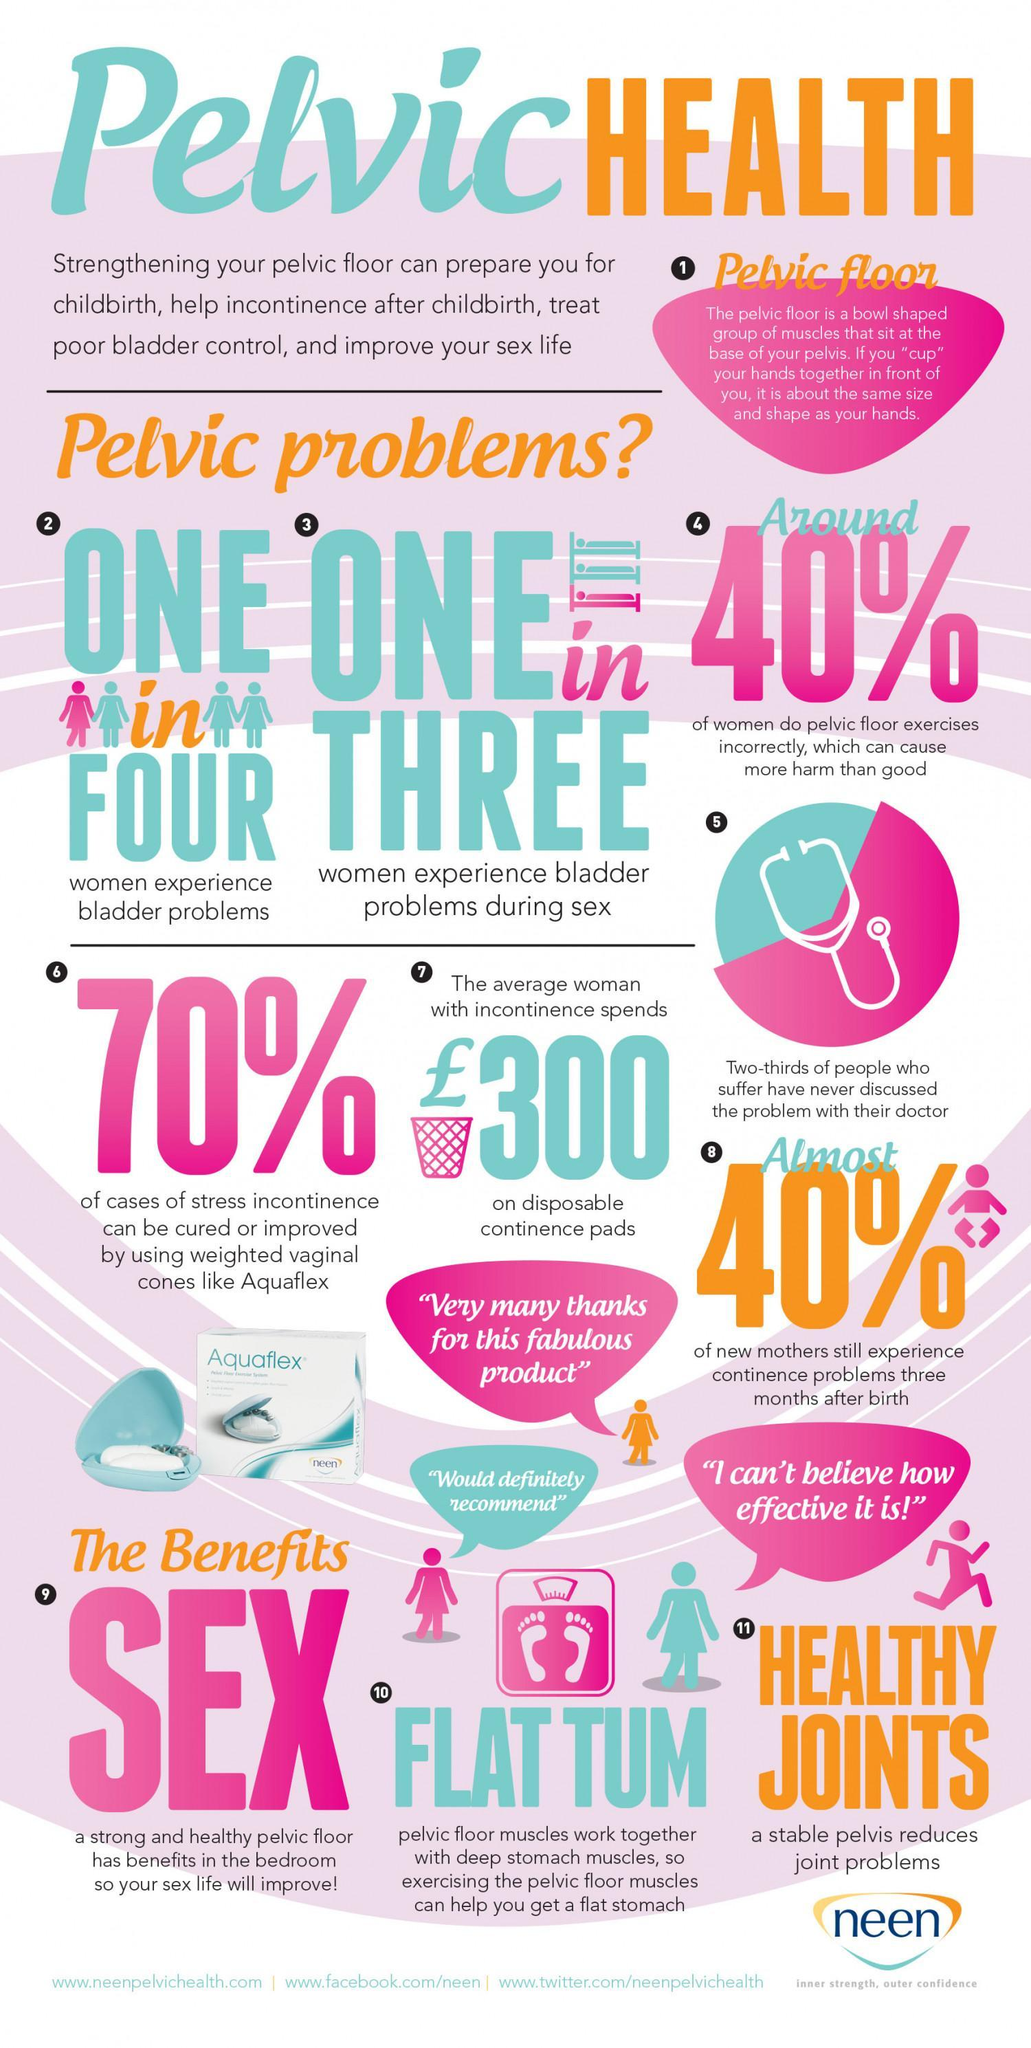What percentage of women suffer from urinary bladder issues?
Answer the question with a short phrase. one in four How many advantages of pelvic floor exercise are listed? 3 What percentage of women face issues when sex due to bladder problems? one in three What are the advantages of pelvic floor exercise? sex, flat tum, healthy joints 